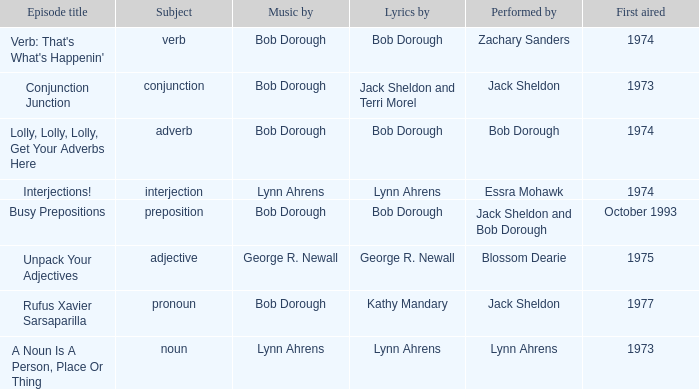When interjection is the subject who are the lyrics by? Lynn Ahrens. 